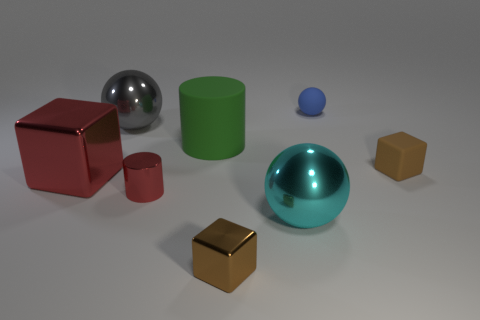Add 1 red cylinders. How many objects exist? 9 Subtract all spheres. How many objects are left? 5 Add 6 small red cylinders. How many small red cylinders are left? 7 Add 6 purple cylinders. How many purple cylinders exist? 6 Subtract 1 cyan spheres. How many objects are left? 7 Subtract all big red objects. Subtract all gray things. How many objects are left? 6 